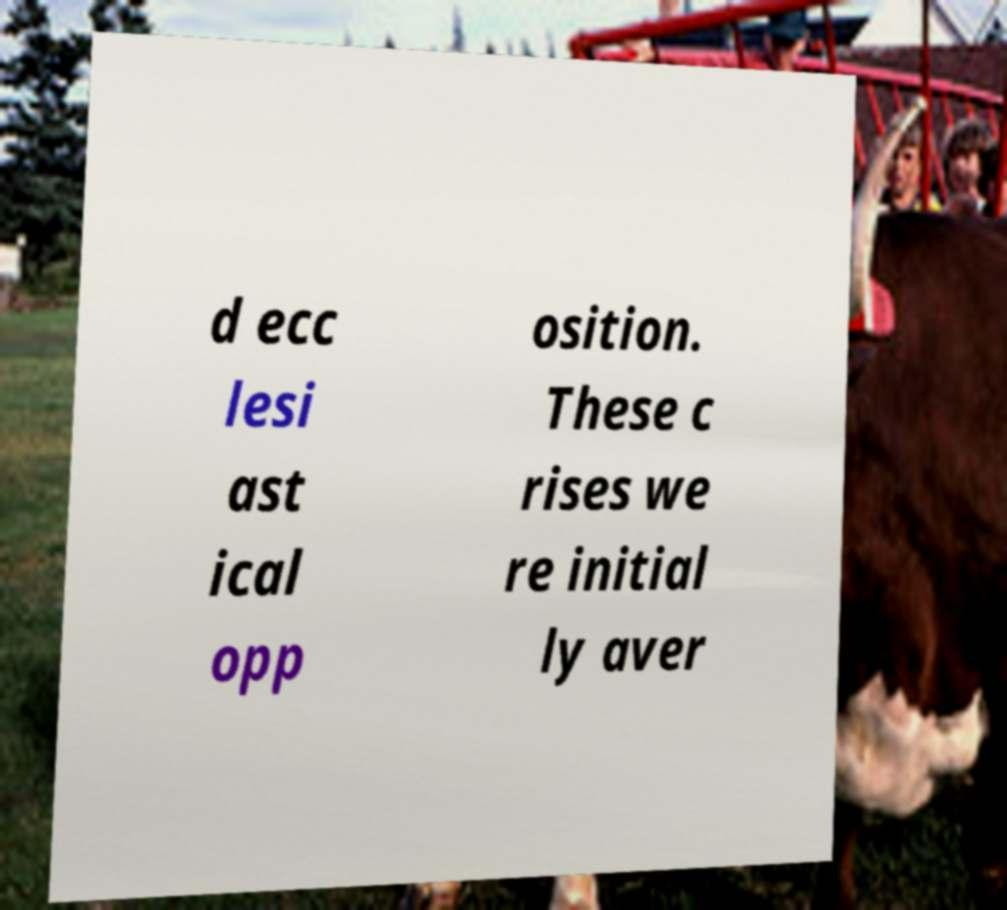For documentation purposes, I need the text within this image transcribed. Could you provide that? d ecc lesi ast ical opp osition. These c rises we re initial ly aver 